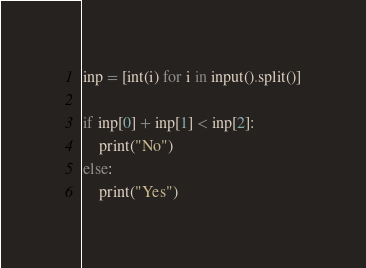<code> <loc_0><loc_0><loc_500><loc_500><_Python_>
inp = [int(i) for i in input().split()]

if inp[0] + inp[1] < inp[2]:
    print("No")
else:
    print("Yes")
</code> 